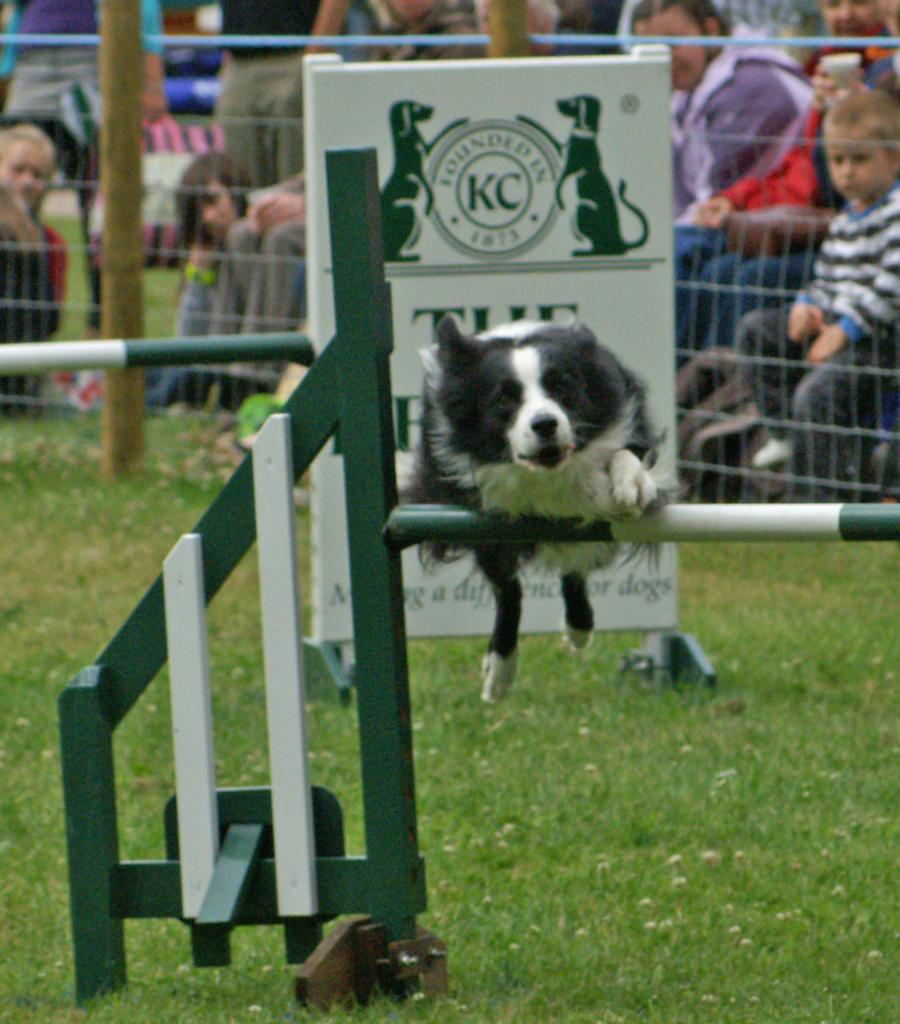What animal can be seen in the image? There is a dog in the image. What is the dog doing in the image? The dog is jumping. What is located at the bottom of the image? There is a gate at the bottom of the image. What can be seen in the background of the image? There is a board and a mesh in the background of the image. Are there any people visible in the image? Yes, there are people sitting in the background of the image. What type of jeans is the dog wearing in the image? There are no jeans present in the image, as dogs do not wear clothing. How long has the year been in progress during the time the image was taken? The image does not provide any information about the time or year it was taken, so it cannot be determined from the image. 